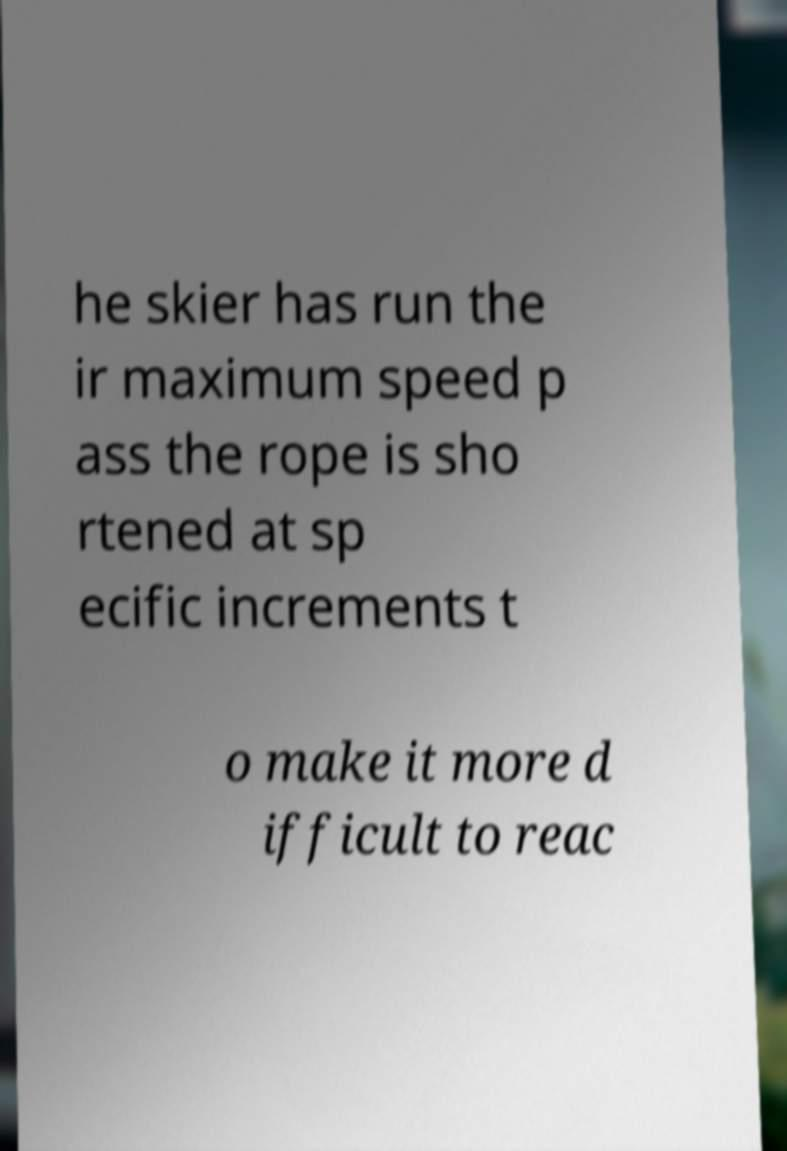Can you accurately transcribe the text from the provided image for me? he skier has run the ir maximum speed p ass the rope is sho rtened at sp ecific increments t o make it more d ifficult to reac 